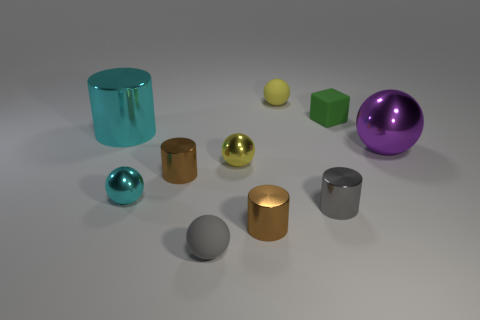Subtract all cyan metallic balls. How many balls are left? 4 Subtract all gray cylinders. How many cylinders are left? 3 Subtract all blue cylinders. Subtract all red blocks. How many cylinders are left? 4 Subtract all cylinders. How many objects are left? 6 Add 7 metallic spheres. How many metallic spheres exist? 10 Subtract 1 gray cylinders. How many objects are left? 9 Subtract all gray rubber balls. Subtract all cyan metallic things. How many objects are left? 7 Add 4 purple things. How many purple things are left? 5 